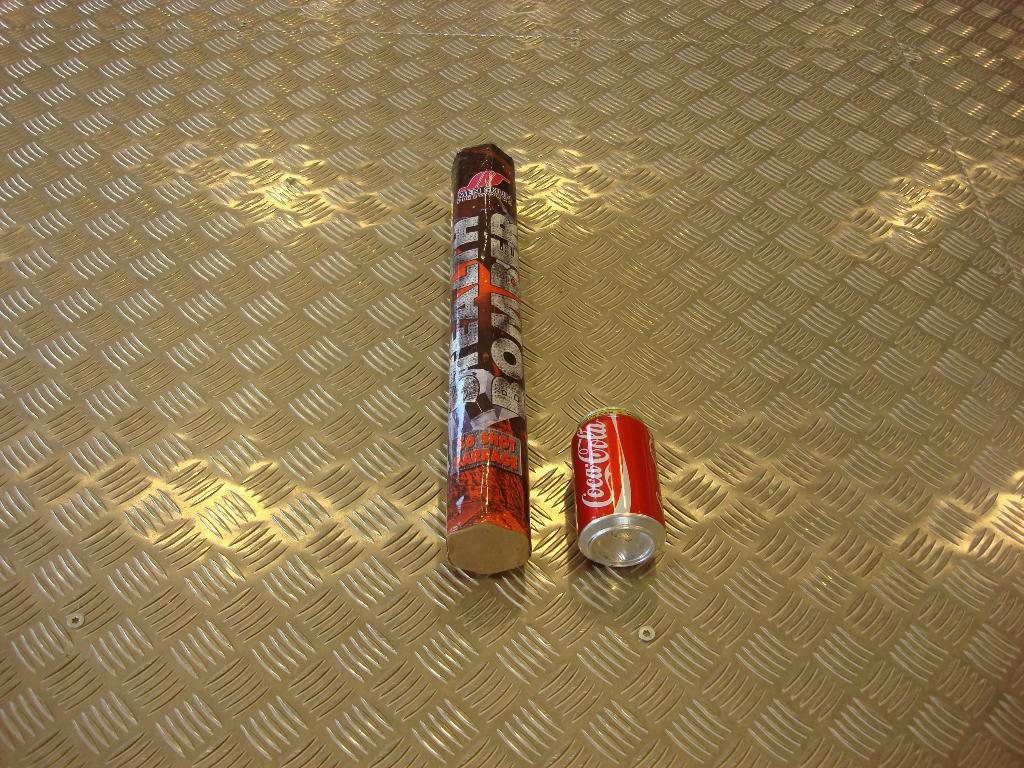<image>
Share a concise interpretation of the image provided. some cans that are on the ground including a coke can 